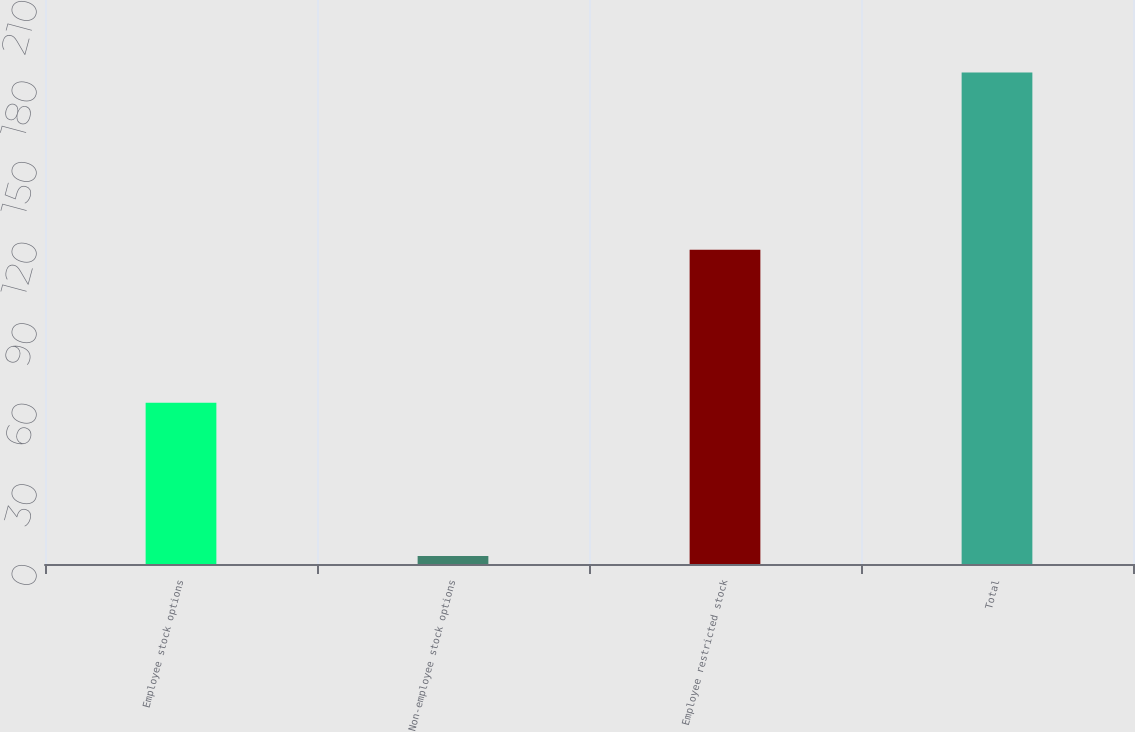Convert chart. <chart><loc_0><loc_0><loc_500><loc_500><bar_chart><fcel>Employee stock options<fcel>Non-employee stock options<fcel>Employee restricted stock<fcel>Total<nl><fcel>60<fcel>3<fcel>117<fcel>183<nl></chart> 